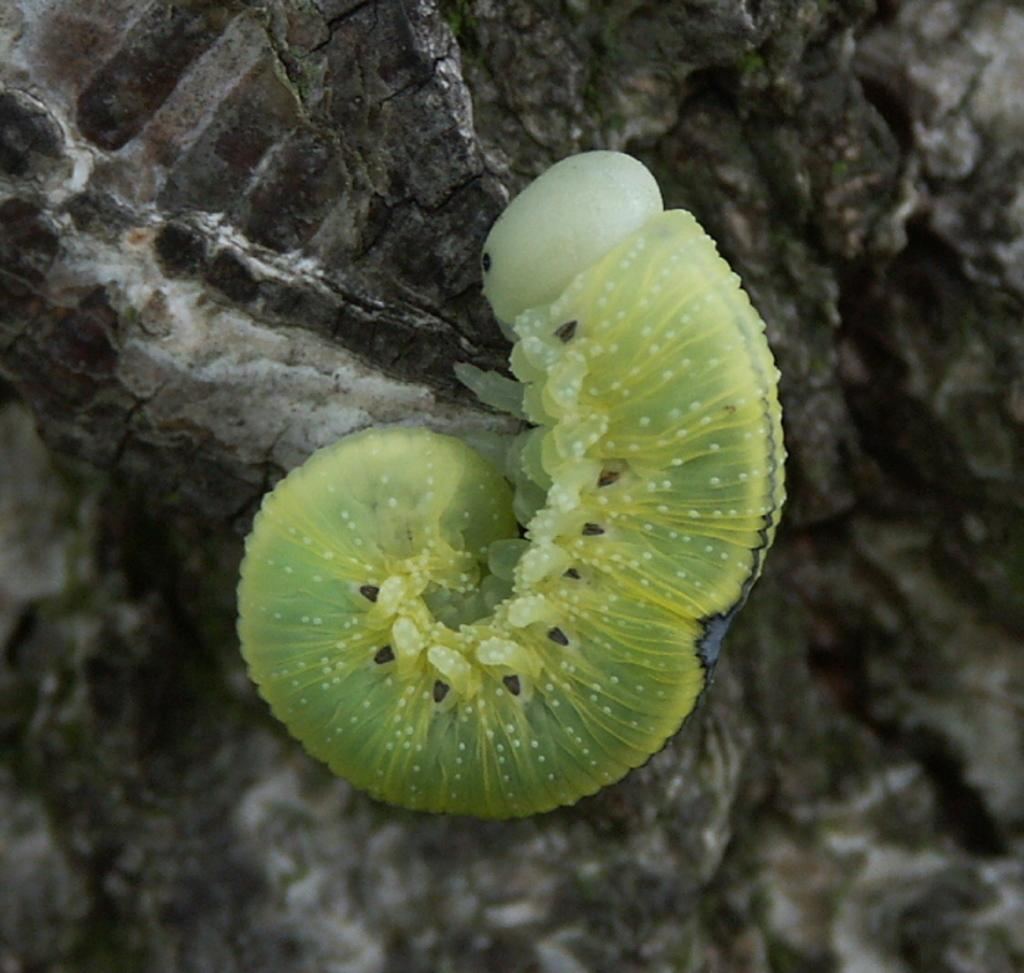What is the main subject of the image? The main subject of the image is a caterpillar. Where is the caterpillar located in the image? The caterpillar is on a rock. What type of brush does the caterpillar use to clean its home in the image? There is no brush present in the image, and caterpillars do not clean their homes. 